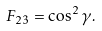Convert formula to latex. <formula><loc_0><loc_0><loc_500><loc_500>F _ { 2 3 } = \cos ^ { 2 } { \gamma } .</formula> 